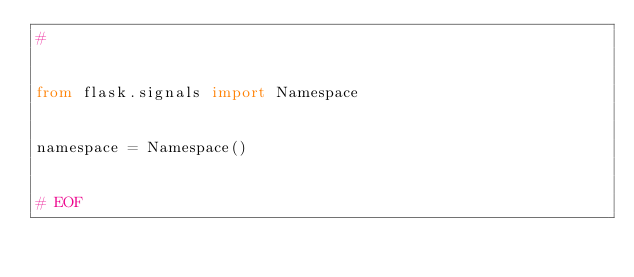<code> <loc_0><loc_0><loc_500><loc_500><_Python_>#


from flask.signals import Namespace


namespace = Namespace()


# EOF
</code> 